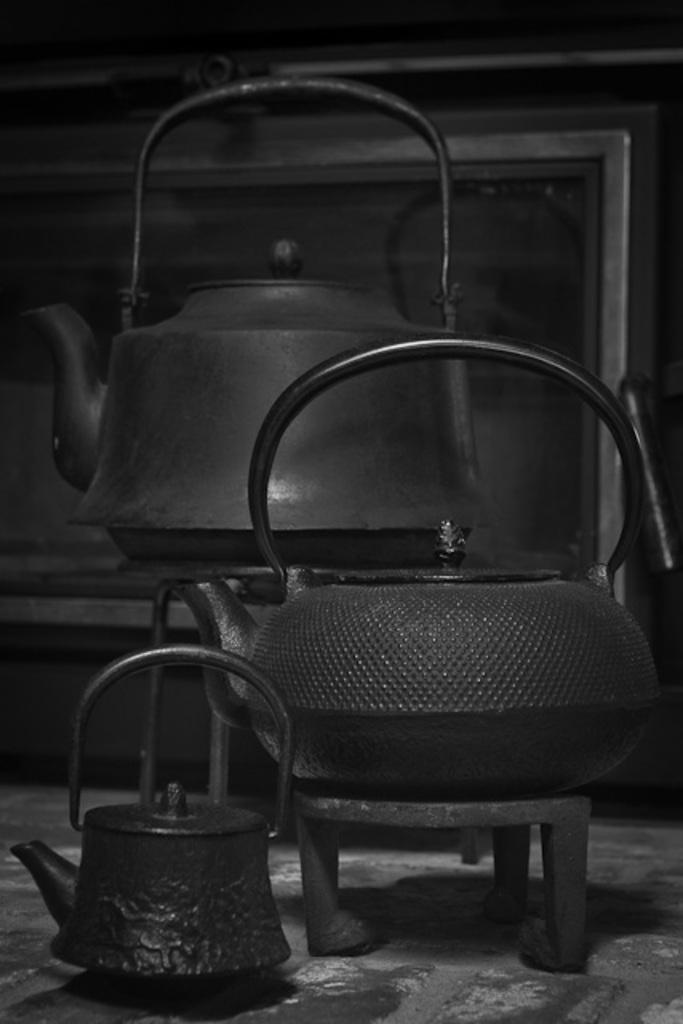What type of objects are present in the image? There are kettles in the image. What color are the kettles? The kettles are black in color. What type of account is being discussed in the image? There is no account being discussed in the image; it features kettles. Can you see any crooks in the image? There are no crooks present in the image; it features kettles. 